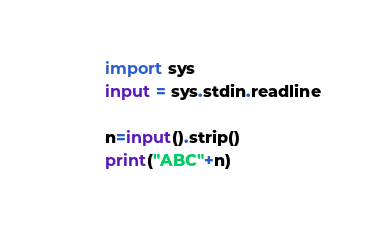Convert code to text. <code><loc_0><loc_0><loc_500><loc_500><_Python_>import sys
input = sys.stdin.readline

n=input().strip()
print("ABC"+n)
</code> 